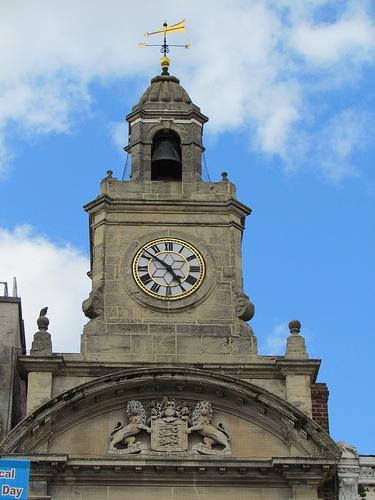Explain what can be found on top of the clock tower. A yellow windmill with yellow arrowheads and a gold weather vane can be found on top of the clock tower. Evaluate the overall sentiment or mood conveyed by the image. The image conveys a peaceful and historical sentiment with the old stone clock tower and serene sky. Analyze the interactions between the two stone lions and the object between them. The two stone lion statues guard a stone tablet placed between them as if protecting or presenting it. Complete this complex reasoning task: If it takes one minute for the minute hand on the clock to move from roman numeral I to II, how long will it take to move from III to IX? It will take six minutes for the minute hand to move from III to IX, since there are six roman numerals between them. What type of structure is prominently featured in the image, and what is its primary color? A large gray stone clock tower is the main structure featured in the image. Provide a brief description of the bell and its material in the image. The bell is an old metal bell, black in color, and is located in the tower. Identify two objects carved into the architecture of the building. Two lion carvings are present in the architecture of the building. Describe the texture and color of the sky in the image. The sky in the image is clear blue with some wispy white clouds. Count the total number of lion statues and carvings in the image. There are four lion figures in the image: two lion statues and two lion carvings. What is the design of the clock's face and what type of numerals does it display? The clock has a white face, black hands, and displays the numbers in Roman numerals. What is the interaction between the bird and the stone? The bird is perched atop the stone. What is the color of the bell in the tower? Old metal, likely black or dark grey. Did you notice the large rainbow in the sky, just above the white clouds? It's spanning across the entire top portion of the image. No, it's not mentioned in the image. Describe the color of the sky in this image. Clear blue Is there a clear blue sky in the image? Yes, there is a clear blue sky. What are the yellow objects on top of the tower? A yellow windmill and yellow arrow heads. What are the positions and dimensions of the white clouds in the sky? 1. X:257 Y:126 Width:77 Height:77, 2. X:3 Y:208 Width:90 Height:90, 3. X:0 Y:241 Width:75 Height:75 Identify the emotions associated with this image. Pride, awe, peacefulness Which object is described as "an ornate stone clocktower"? The object at X:26 Y:126 Width:321 Height:321. Describe the quality of the image details. The image details are clear and well-defined. Can you spot the beautiful unicorn standing behind the lions? It's white with a golden horn and majestic wings. Unicorns are mythical creatures and do not exist in real life, so this instruction is misleading as there cannot be a unicorn in the image. What object is located between two lions? A grey stone statue and a stone tablet. What time does the clock say? 5:53 Which object is the largest in the image? A large stone building List all objects mentioned in the given information. Stone building, metal bell, bird, stone lion statues, stone tablet, blue sign, clock, clouds, stone tower, windmill, arrow heads, arch, red brick, weather vane, clock hands Describe the visual appearance of the clock. A large circular clock with roman numerals, a white face, black hands, and a six-pointed golden star. Segment the parts of the clock in the image. Clock face, hour hand, minute hand, roman numerals, golden star Read the text on the blue sign. Cal day Detect any unusual objects or features in the image. No unusual objects or features detected. What kind of hands does the clock have? Hour hand and minute hand, both black. I suggest paying close attention to the hidden treasure chest between the stone lions. You might even catch a glimpse of gold coins inside. This instruction is misleading because there is no mention of a treasure chest in the given information. Rather, there is only a stone tablet between the lions. Identify the two objects carved into the architecture. Two lion carvings 